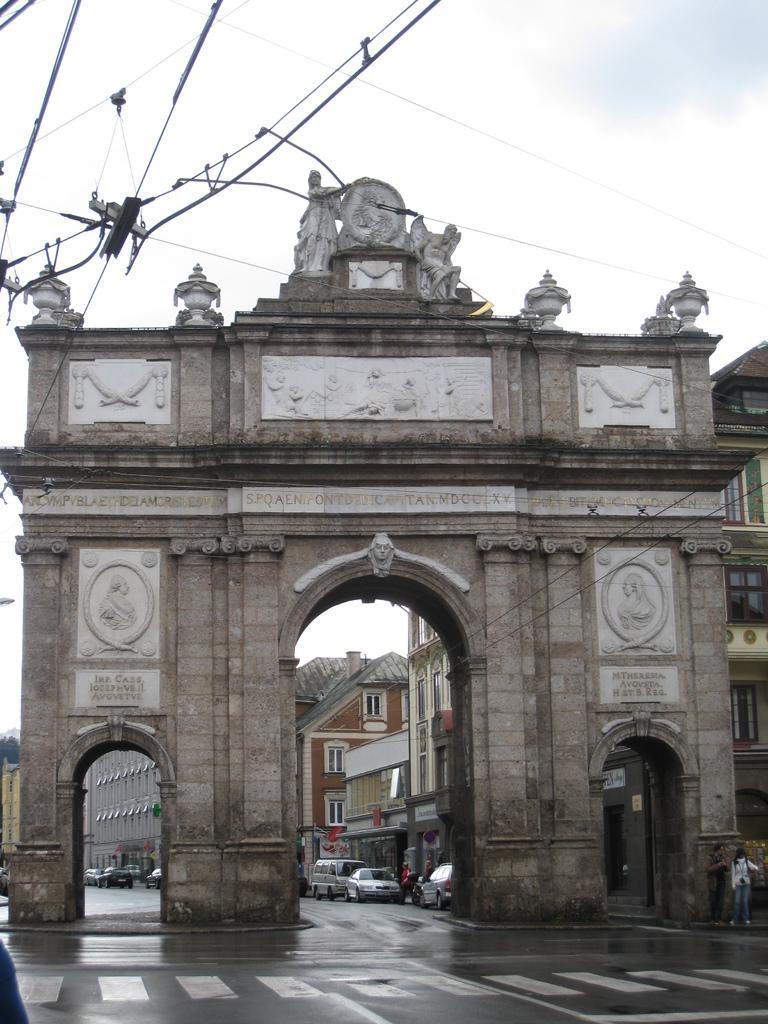How would you summarize this image in a sentence or two? This picture is clicked outside. In the foreground we can see a zebra crossing and a person standing on the ground. In the center there is a building and the sculptures and we can see the vehicles parked on the ground. In the background there is a sky and the buildings. At the top we can see the cables. 